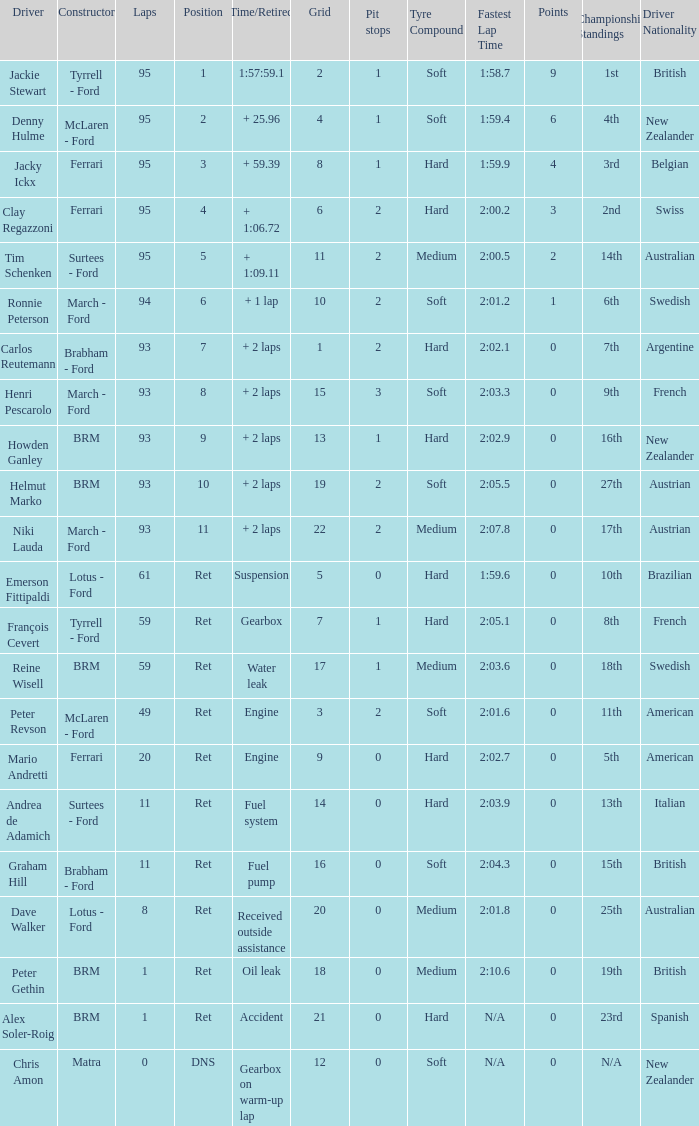How many grids does dave walker have? 1.0. 